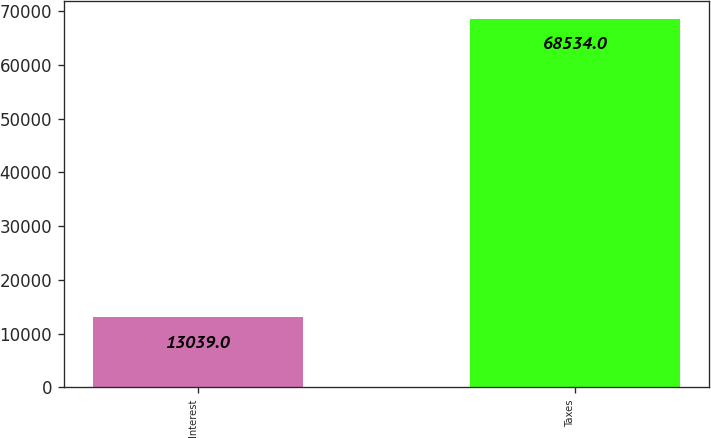Convert chart to OTSL. <chart><loc_0><loc_0><loc_500><loc_500><bar_chart><fcel>Interest<fcel>Taxes<nl><fcel>13039<fcel>68534<nl></chart> 